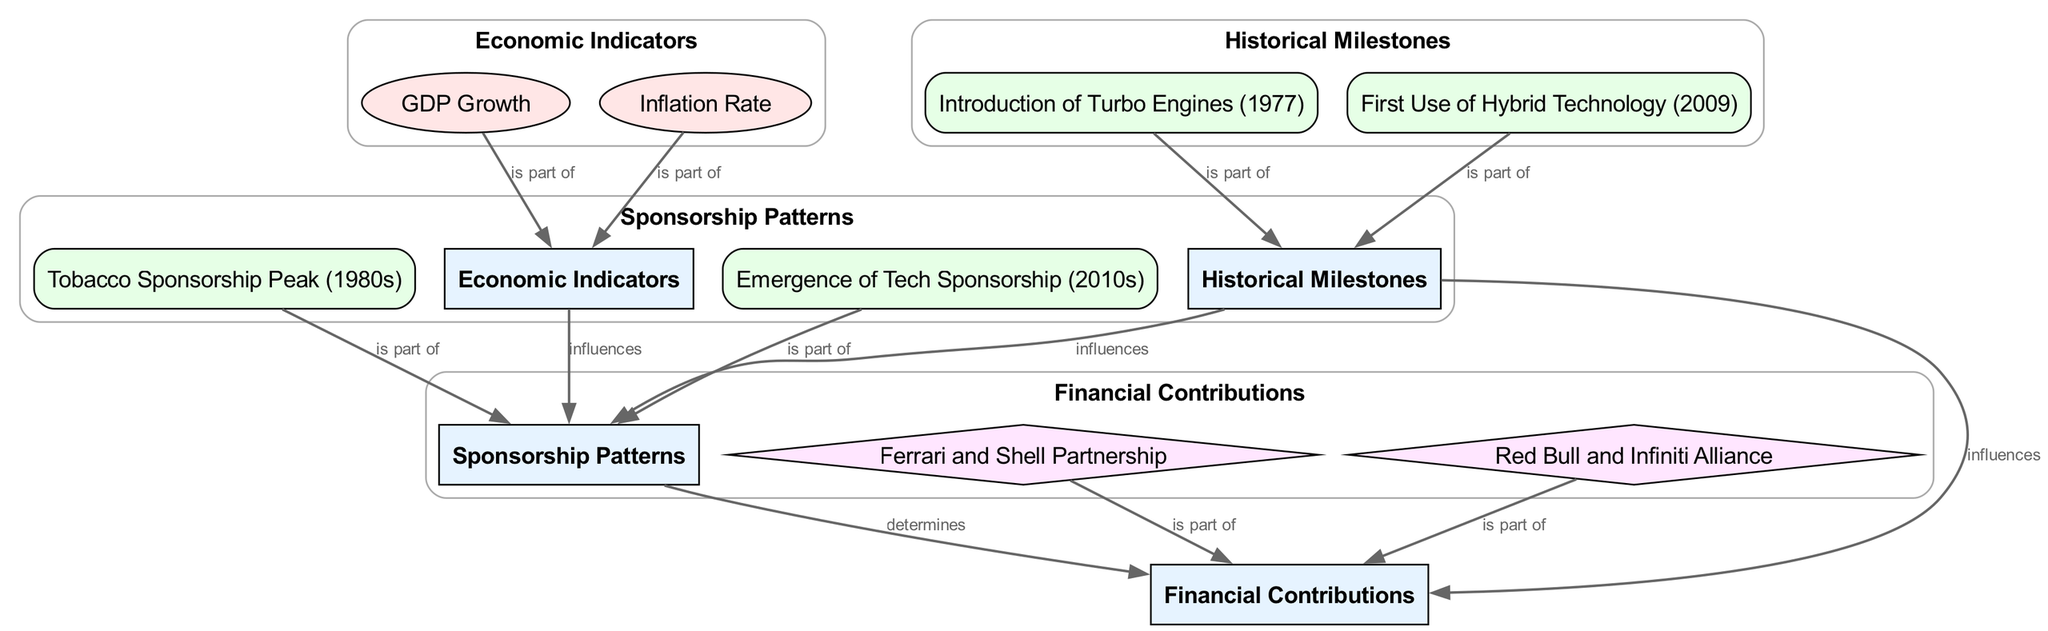What are the factors listed under Economic Indicators? The diagram indicates that under Economic Indicators, there are two factors: GDP Growth and Inflation Rate. These factors are connected to the Economic Indicators category node and illustrate components that affect sponsorship patterns.
Answer: GDP Growth, Inflation Rate How many historical milestones are depicted in the diagram? The diagram shows two historical milestones: the Introduction of Turbo Engines (1977) and the First Use of Hybrid Technology (2009). These milestones are connected to the Historical Milestones category.
Answer: 2 What type of sponsorship peaked in the 1980s? The diagram states that Tobacco Sponsorship Peak in the 1980s is a significant event. This event is linked to the Sponsorship Patterns category, indicating its importance in that time period.
Answer: Tobacco Sponsorship Peak What influences Sponsorship Patterns according to the diagram? The diagram asserts that both Economic Indicators and Historical Milestones influence Sponsorship Patterns. To find the answer, I traced edges from these categories to the Sponsorship Patterns node.
Answer: Economic Indicators, Historical Milestones Which companies are mentioned in financial contributions? The diagram indicates two relationships under Financial Contributions: Ferrari and Shell Partnership, and Red Bull and Infiniti Alliance. These relationships show specific contributions tied to sponsorships in the racing industry.
Answer: Ferrari and Shell Partnership, Red Bull and Infiniti Alliance What is the connection between Inflation Rate and Sponsorship Patterns? According to the diagram, Inflation Rate is indicated as part of Economic Indicators, which influences Sponsorship Patterns. This connection establishes that changes in inflation may affect sponsorship decisions.
Answer: Influences What historical event reflects the emergence of tech sponsorship? The diagram notes that the Emergence of Tech Sponsorship occurred in the 2010s. This event is positioned under Sponsorship Patterns and shows a trend in modern sponsorship strategies.
Answer: Emergence of Tech Sponsorship (2010s) How do Historical Milestones affect Financial Contributions? The diagram reveals that Historical Milestones influence Financial Contributions, demonstrating how significant events can shape the financial involvement of companies in racing. To arrive at the answer, I traced the edges from Historical Milestones to Financial Contributions.
Answer: Influences 